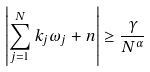<formula> <loc_0><loc_0><loc_500><loc_500>\left | \sum _ { j = 1 } ^ { N } k _ { j } \omega _ { j } + n \right | \geq \frac { \gamma } { N ^ { \alpha } }</formula> 